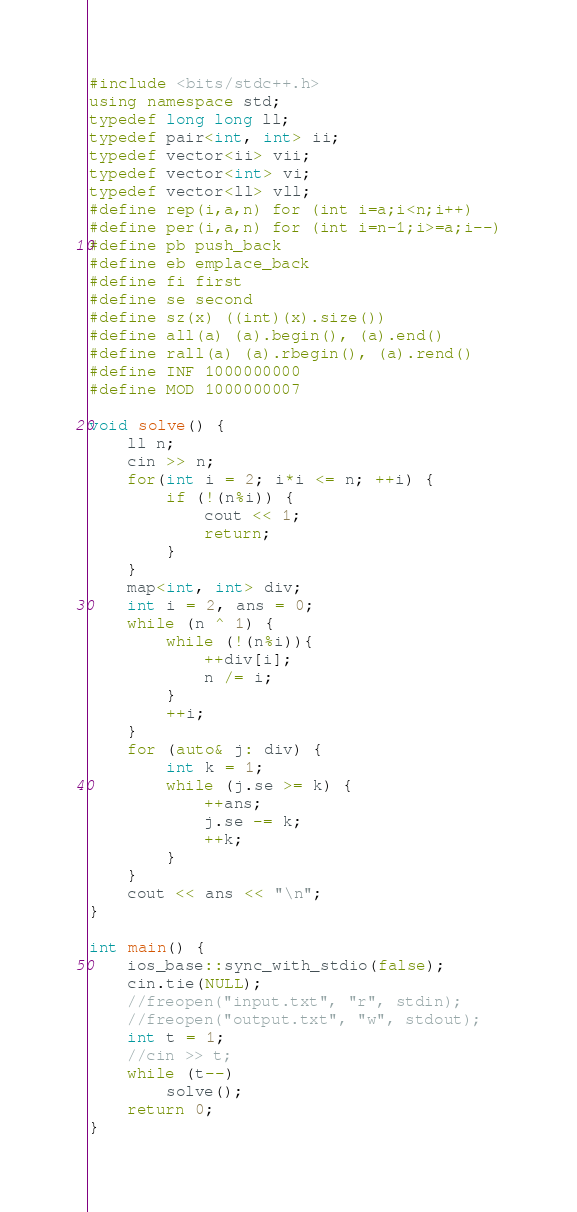<code> <loc_0><loc_0><loc_500><loc_500><_C++_>#include <bits/stdc++.h>
using namespace std;
typedef long long ll;
typedef pair<int, int> ii;
typedef vector<ii> vii;
typedef vector<int> vi;
typedef vector<ll> vll;
#define rep(i,a,n) for (int i=a;i<n;i++)
#define per(i,a,n) for (int i=n-1;i>=a;i--)
#define pb push_back
#define eb emplace_back
#define fi first
#define se second
#define sz(x) ((int)(x).size())
#define all(a) (a).begin(), (a).end()
#define rall(a) (a).rbegin(), (a).rend()
#define INF 1000000000
#define MOD 1000000007

void solve() {
    ll n;
    cin >> n;
    for(int i = 2; i*i <= n; ++i) {
        if (!(n%i)) {
            cout << 1;
            return;
        }
    }
    map<int, int> div;
    int i = 2, ans = 0;
    while (n ^ 1) {
        while (!(n%i)){
            ++div[i];
            n /= i;
        }
        ++i;
    }
    for (auto& j: div) {
        int k = 1;
        while (j.se >= k) {
            ++ans;
            j.se -= k;
            ++k;
        }
    }
    cout << ans << "\n";
}

int main() {
    ios_base::sync_with_stdio(false);
    cin.tie(NULL);
    //freopen("input.txt", "r", stdin);
    //freopen("output.txt", "w", stdout);
    int t = 1;
    //cin >> t;
    while (t--)
        solve();
    return 0;
}

</code> 